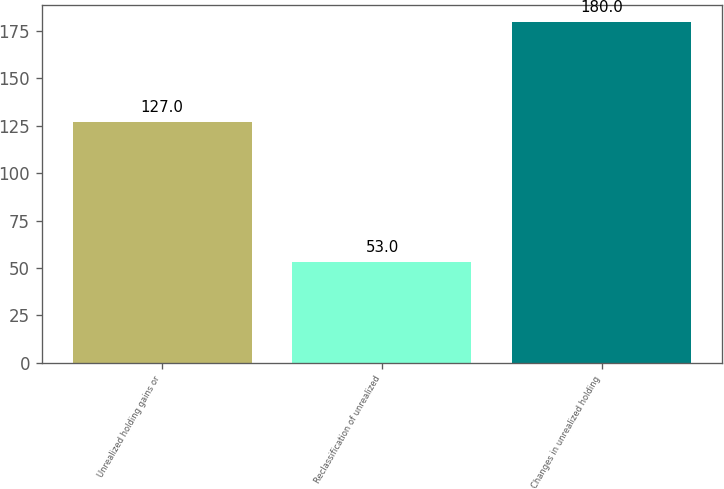<chart> <loc_0><loc_0><loc_500><loc_500><bar_chart><fcel>Unrealized holding gains or<fcel>Reclassification of unrealized<fcel>Changes in unrealized holding<nl><fcel>127<fcel>53<fcel>180<nl></chart> 